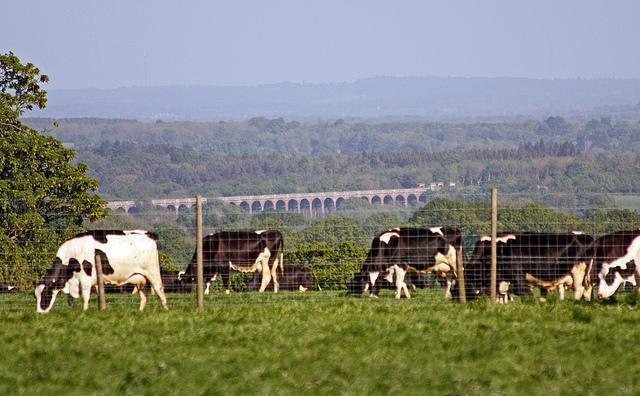The cow belongs to which genus?
From the following four choices, select the correct answer to address the question.
Options: Bovinae, bovidae, bos, cattle. Bos. 